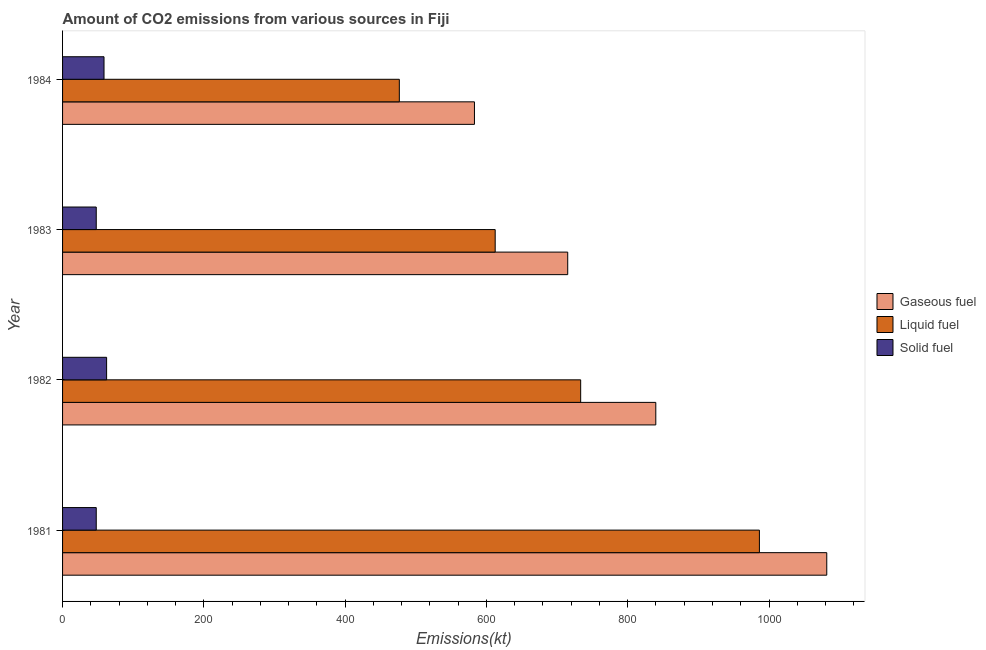How many different coloured bars are there?
Make the answer very short. 3. How many groups of bars are there?
Offer a terse response. 4. Are the number of bars on each tick of the Y-axis equal?
Offer a very short reply. Yes. How many bars are there on the 4th tick from the top?
Your answer should be compact. 3. How many bars are there on the 2nd tick from the bottom?
Make the answer very short. 3. What is the label of the 4th group of bars from the top?
Your answer should be very brief. 1981. What is the amount of co2 emissions from gaseous fuel in 1981?
Offer a terse response. 1081.77. Across all years, what is the maximum amount of co2 emissions from liquid fuel?
Give a very brief answer. 986.42. Across all years, what is the minimum amount of co2 emissions from liquid fuel?
Offer a terse response. 476.71. What is the total amount of co2 emissions from solid fuel in the graph?
Your response must be concise. 216.35. What is the difference between the amount of co2 emissions from gaseous fuel in 1981 and that in 1983?
Provide a short and direct response. 366.7. What is the difference between the amount of co2 emissions from gaseous fuel in 1983 and the amount of co2 emissions from liquid fuel in 1981?
Ensure brevity in your answer.  -271.36. What is the average amount of co2 emissions from gaseous fuel per year?
Your answer should be very brief. 804.91. In the year 1981, what is the difference between the amount of co2 emissions from gaseous fuel and amount of co2 emissions from liquid fuel?
Provide a succinct answer. 95.34. What is the ratio of the amount of co2 emissions from liquid fuel in 1981 to that in 1982?
Keep it short and to the point. 1.34. Is the amount of co2 emissions from gaseous fuel in 1981 less than that in 1983?
Your answer should be compact. No. Is the difference between the amount of co2 emissions from solid fuel in 1981 and 1984 greater than the difference between the amount of co2 emissions from liquid fuel in 1981 and 1984?
Offer a terse response. No. What is the difference between the highest and the second highest amount of co2 emissions from gaseous fuel?
Your answer should be compact. 242.02. What is the difference between the highest and the lowest amount of co2 emissions from gaseous fuel?
Keep it short and to the point. 498.71. What does the 1st bar from the top in 1984 represents?
Offer a terse response. Solid fuel. What does the 1st bar from the bottom in 1981 represents?
Make the answer very short. Gaseous fuel. Is it the case that in every year, the sum of the amount of co2 emissions from gaseous fuel and amount of co2 emissions from liquid fuel is greater than the amount of co2 emissions from solid fuel?
Your answer should be very brief. Yes. How many bars are there?
Give a very brief answer. 12. Are all the bars in the graph horizontal?
Ensure brevity in your answer.  Yes. Where does the legend appear in the graph?
Offer a very short reply. Center right. What is the title of the graph?
Offer a terse response. Amount of CO2 emissions from various sources in Fiji. What is the label or title of the X-axis?
Offer a terse response. Emissions(kt). What is the Emissions(kt) in Gaseous fuel in 1981?
Give a very brief answer. 1081.77. What is the Emissions(kt) of Liquid fuel in 1981?
Keep it short and to the point. 986.42. What is the Emissions(kt) of Solid fuel in 1981?
Your response must be concise. 47.67. What is the Emissions(kt) of Gaseous fuel in 1982?
Keep it short and to the point. 839.74. What is the Emissions(kt) of Liquid fuel in 1982?
Your answer should be very brief. 733.4. What is the Emissions(kt) of Solid fuel in 1982?
Your answer should be compact. 62.34. What is the Emissions(kt) of Gaseous fuel in 1983?
Your answer should be very brief. 715.07. What is the Emissions(kt) in Liquid fuel in 1983?
Provide a short and direct response. 612.39. What is the Emissions(kt) of Solid fuel in 1983?
Keep it short and to the point. 47.67. What is the Emissions(kt) in Gaseous fuel in 1984?
Make the answer very short. 583.05. What is the Emissions(kt) of Liquid fuel in 1984?
Offer a very short reply. 476.71. What is the Emissions(kt) in Solid fuel in 1984?
Offer a terse response. 58.67. Across all years, what is the maximum Emissions(kt) in Gaseous fuel?
Your answer should be very brief. 1081.77. Across all years, what is the maximum Emissions(kt) of Liquid fuel?
Give a very brief answer. 986.42. Across all years, what is the maximum Emissions(kt) in Solid fuel?
Make the answer very short. 62.34. Across all years, what is the minimum Emissions(kt) in Gaseous fuel?
Your response must be concise. 583.05. Across all years, what is the minimum Emissions(kt) of Liquid fuel?
Your response must be concise. 476.71. Across all years, what is the minimum Emissions(kt) of Solid fuel?
Offer a very short reply. 47.67. What is the total Emissions(kt) of Gaseous fuel in the graph?
Give a very brief answer. 3219.63. What is the total Emissions(kt) in Liquid fuel in the graph?
Keep it short and to the point. 2808.92. What is the total Emissions(kt) of Solid fuel in the graph?
Ensure brevity in your answer.  216.35. What is the difference between the Emissions(kt) of Gaseous fuel in 1981 and that in 1982?
Your response must be concise. 242.02. What is the difference between the Emissions(kt) of Liquid fuel in 1981 and that in 1982?
Your answer should be compact. 253.02. What is the difference between the Emissions(kt) of Solid fuel in 1981 and that in 1982?
Give a very brief answer. -14.67. What is the difference between the Emissions(kt) in Gaseous fuel in 1981 and that in 1983?
Provide a succinct answer. 366.7. What is the difference between the Emissions(kt) of Liquid fuel in 1981 and that in 1983?
Your answer should be very brief. 374.03. What is the difference between the Emissions(kt) in Solid fuel in 1981 and that in 1983?
Your answer should be compact. 0. What is the difference between the Emissions(kt) of Gaseous fuel in 1981 and that in 1984?
Your response must be concise. 498.71. What is the difference between the Emissions(kt) in Liquid fuel in 1981 and that in 1984?
Your answer should be compact. 509.71. What is the difference between the Emissions(kt) of Solid fuel in 1981 and that in 1984?
Your response must be concise. -11. What is the difference between the Emissions(kt) in Gaseous fuel in 1982 and that in 1983?
Offer a terse response. 124.68. What is the difference between the Emissions(kt) in Liquid fuel in 1982 and that in 1983?
Give a very brief answer. 121.01. What is the difference between the Emissions(kt) of Solid fuel in 1982 and that in 1983?
Your response must be concise. 14.67. What is the difference between the Emissions(kt) of Gaseous fuel in 1982 and that in 1984?
Your answer should be very brief. 256.69. What is the difference between the Emissions(kt) of Liquid fuel in 1982 and that in 1984?
Ensure brevity in your answer.  256.69. What is the difference between the Emissions(kt) in Solid fuel in 1982 and that in 1984?
Ensure brevity in your answer.  3.67. What is the difference between the Emissions(kt) in Gaseous fuel in 1983 and that in 1984?
Give a very brief answer. 132.01. What is the difference between the Emissions(kt) in Liquid fuel in 1983 and that in 1984?
Your answer should be compact. 135.68. What is the difference between the Emissions(kt) of Solid fuel in 1983 and that in 1984?
Your answer should be very brief. -11. What is the difference between the Emissions(kt) in Gaseous fuel in 1981 and the Emissions(kt) in Liquid fuel in 1982?
Provide a succinct answer. 348.37. What is the difference between the Emissions(kt) of Gaseous fuel in 1981 and the Emissions(kt) of Solid fuel in 1982?
Make the answer very short. 1019.43. What is the difference between the Emissions(kt) of Liquid fuel in 1981 and the Emissions(kt) of Solid fuel in 1982?
Make the answer very short. 924.08. What is the difference between the Emissions(kt) of Gaseous fuel in 1981 and the Emissions(kt) of Liquid fuel in 1983?
Your answer should be compact. 469.38. What is the difference between the Emissions(kt) in Gaseous fuel in 1981 and the Emissions(kt) in Solid fuel in 1983?
Provide a short and direct response. 1034.09. What is the difference between the Emissions(kt) in Liquid fuel in 1981 and the Emissions(kt) in Solid fuel in 1983?
Keep it short and to the point. 938.75. What is the difference between the Emissions(kt) of Gaseous fuel in 1981 and the Emissions(kt) of Liquid fuel in 1984?
Keep it short and to the point. 605.05. What is the difference between the Emissions(kt) in Gaseous fuel in 1981 and the Emissions(kt) in Solid fuel in 1984?
Provide a short and direct response. 1023.09. What is the difference between the Emissions(kt) of Liquid fuel in 1981 and the Emissions(kt) of Solid fuel in 1984?
Make the answer very short. 927.75. What is the difference between the Emissions(kt) of Gaseous fuel in 1982 and the Emissions(kt) of Liquid fuel in 1983?
Provide a short and direct response. 227.35. What is the difference between the Emissions(kt) in Gaseous fuel in 1982 and the Emissions(kt) in Solid fuel in 1983?
Provide a short and direct response. 792.07. What is the difference between the Emissions(kt) of Liquid fuel in 1982 and the Emissions(kt) of Solid fuel in 1983?
Provide a short and direct response. 685.73. What is the difference between the Emissions(kt) in Gaseous fuel in 1982 and the Emissions(kt) in Liquid fuel in 1984?
Offer a terse response. 363.03. What is the difference between the Emissions(kt) of Gaseous fuel in 1982 and the Emissions(kt) of Solid fuel in 1984?
Your answer should be compact. 781.07. What is the difference between the Emissions(kt) of Liquid fuel in 1982 and the Emissions(kt) of Solid fuel in 1984?
Make the answer very short. 674.73. What is the difference between the Emissions(kt) of Gaseous fuel in 1983 and the Emissions(kt) of Liquid fuel in 1984?
Offer a very short reply. 238.35. What is the difference between the Emissions(kt) in Gaseous fuel in 1983 and the Emissions(kt) in Solid fuel in 1984?
Your response must be concise. 656.39. What is the difference between the Emissions(kt) in Liquid fuel in 1983 and the Emissions(kt) in Solid fuel in 1984?
Ensure brevity in your answer.  553.72. What is the average Emissions(kt) of Gaseous fuel per year?
Provide a short and direct response. 804.91. What is the average Emissions(kt) in Liquid fuel per year?
Make the answer very short. 702.23. What is the average Emissions(kt) in Solid fuel per year?
Provide a short and direct response. 54.09. In the year 1981, what is the difference between the Emissions(kt) in Gaseous fuel and Emissions(kt) in Liquid fuel?
Your answer should be compact. 95.34. In the year 1981, what is the difference between the Emissions(kt) in Gaseous fuel and Emissions(kt) in Solid fuel?
Keep it short and to the point. 1034.09. In the year 1981, what is the difference between the Emissions(kt) in Liquid fuel and Emissions(kt) in Solid fuel?
Your response must be concise. 938.75. In the year 1982, what is the difference between the Emissions(kt) of Gaseous fuel and Emissions(kt) of Liquid fuel?
Give a very brief answer. 106.34. In the year 1982, what is the difference between the Emissions(kt) in Gaseous fuel and Emissions(kt) in Solid fuel?
Provide a short and direct response. 777.4. In the year 1982, what is the difference between the Emissions(kt) in Liquid fuel and Emissions(kt) in Solid fuel?
Provide a short and direct response. 671.06. In the year 1983, what is the difference between the Emissions(kt) in Gaseous fuel and Emissions(kt) in Liquid fuel?
Make the answer very short. 102.68. In the year 1983, what is the difference between the Emissions(kt) in Gaseous fuel and Emissions(kt) in Solid fuel?
Provide a short and direct response. 667.39. In the year 1983, what is the difference between the Emissions(kt) in Liquid fuel and Emissions(kt) in Solid fuel?
Offer a very short reply. 564.72. In the year 1984, what is the difference between the Emissions(kt) in Gaseous fuel and Emissions(kt) in Liquid fuel?
Offer a terse response. 106.34. In the year 1984, what is the difference between the Emissions(kt) in Gaseous fuel and Emissions(kt) in Solid fuel?
Your answer should be very brief. 524.38. In the year 1984, what is the difference between the Emissions(kt) of Liquid fuel and Emissions(kt) of Solid fuel?
Provide a short and direct response. 418.04. What is the ratio of the Emissions(kt) in Gaseous fuel in 1981 to that in 1982?
Keep it short and to the point. 1.29. What is the ratio of the Emissions(kt) in Liquid fuel in 1981 to that in 1982?
Your response must be concise. 1.34. What is the ratio of the Emissions(kt) in Solid fuel in 1981 to that in 1982?
Offer a terse response. 0.76. What is the ratio of the Emissions(kt) of Gaseous fuel in 1981 to that in 1983?
Your answer should be very brief. 1.51. What is the ratio of the Emissions(kt) of Liquid fuel in 1981 to that in 1983?
Provide a succinct answer. 1.61. What is the ratio of the Emissions(kt) of Gaseous fuel in 1981 to that in 1984?
Ensure brevity in your answer.  1.86. What is the ratio of the Emissions(kt) of Liquid fuel in 1981 to that in 1984?
Your response must be concise. 2.07. What is the ratio of the Emissions(kt) in Solid fuel in 1981 to that in 1984?
Make the answer very short. 0.81. What is the ratio of the Emissions(kt) of Gaseous fuel in 1982 to that in 1983?
Ensure brevity in your answer.  1.17. What is the ratio of the Emissions(kt) in Liquid fuel in 1982 to that in 1983?
Provide a succinct answer. 1.2. What is the ratio of the Emissions(kt) in Solid fuel in 1982 to that in 1983?
Offer a very short reply. 1.31. What is the ratio of the Emissions(kt) in Gaseous fuel in 1982 to that in 1984?
Your response must be concise. 1.44. What is the ratio of the Emissions(kt) of Liquid fuel in 1982 to that in 1984?
Provide a short and direct response. 1.54. What is the ratio of the Emissions(kt) in Solid fuel in 1982 to that in 1984?
Provide a short and direct response. 1.06. What is the ratio of the Emissions(kt) of Gaseous fuel in 1983 to that in 1984?
Your answer should be very brief. 1.23. What is the ratio of the Emissions(kt) of Liquid fuel in 1983 to that in 1984?
Your answer should be compact. 1.28. What is the ratio of the Emissions(kt) of Solid fuel in 1983 to that in 1984?
Ensure brevity in your answer.  0.81. What is the difference between the highest and the second highest Emissions(kt) in Gaseous fuel?
Make the answer very short. 242.02. What is the difference between the highest and the second highest Emissions(kt) of Liquid fuel?
Your answer should be very brief. 253.02. What is the difference between the highest and the second highest Emissions(kt) in Solid fuel?
Give a very brief answer. 3.67. What is the difference between the highest and the lowest Emissions(kt) in Gaseous fuel?
Your response must be concise. 498.71. What is the difference between the highest and the lowest Emissions(kt) of Liquid fuel?
Your answer should be very brief. 509.71. What is the difference between the highest and the lowest Emissions(kt) of Solid fuel?
Give a very brief answer. 14.67. 